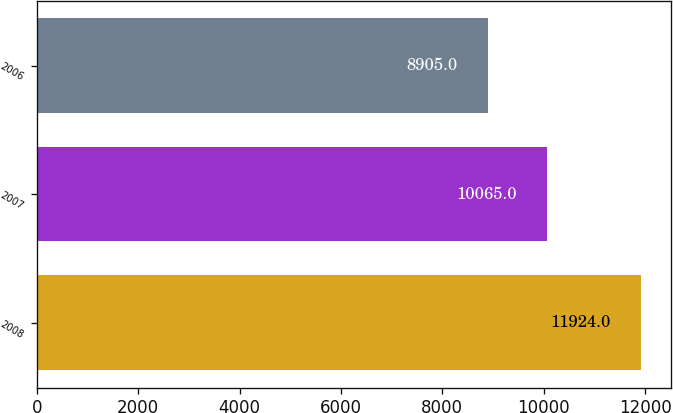Convert chart. <chart><loc_0><loc_0><loc_500><loc_500><bar_chart><fcel>2008<fcel>2007<fcel>2006<nl><fcel>11924<fcel>10065<fcel>8905<nl></chart> 